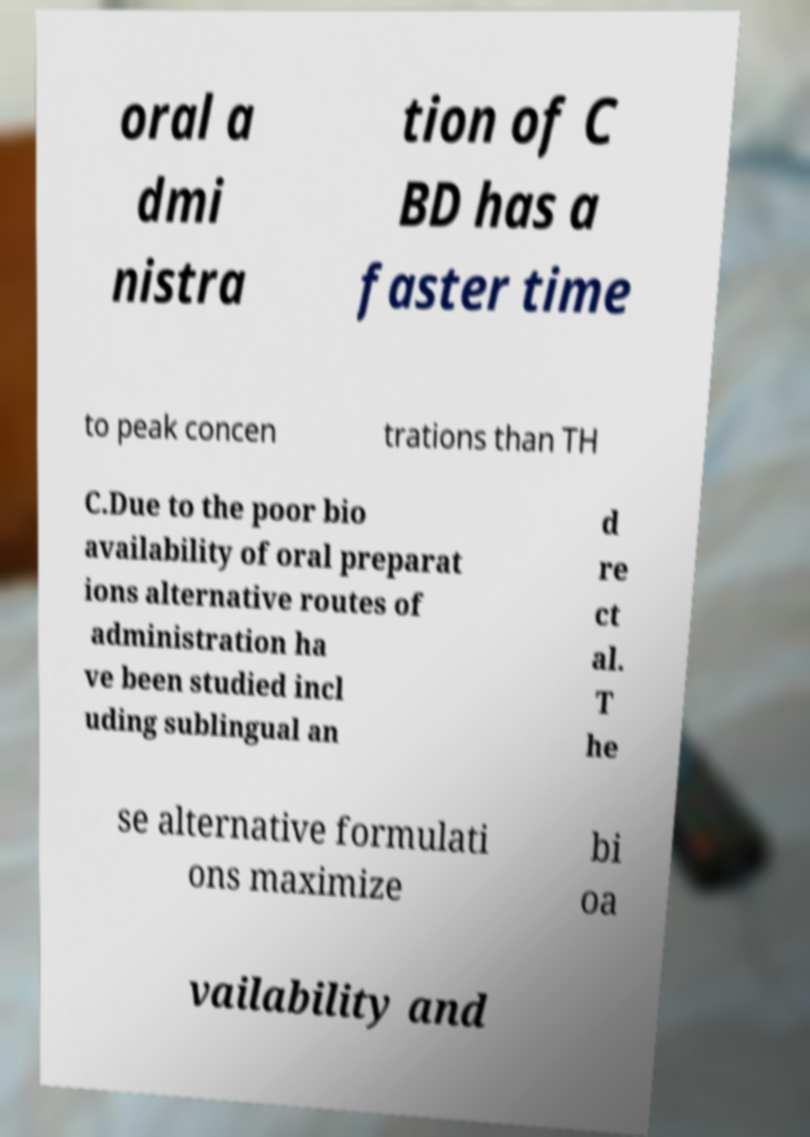There's text embedded in this image that I need extracted. Can you transcribe it verbatim? oral a dmi nistra tion of C BD has a faster time to peak concen trations than TH C.Due to the poor bio availability of oral preparat ions alternative routes of administration ha ve been studied incl uding sublingual an d re ct al. T he se alternative formulati ons maximize bi oa vailability and 